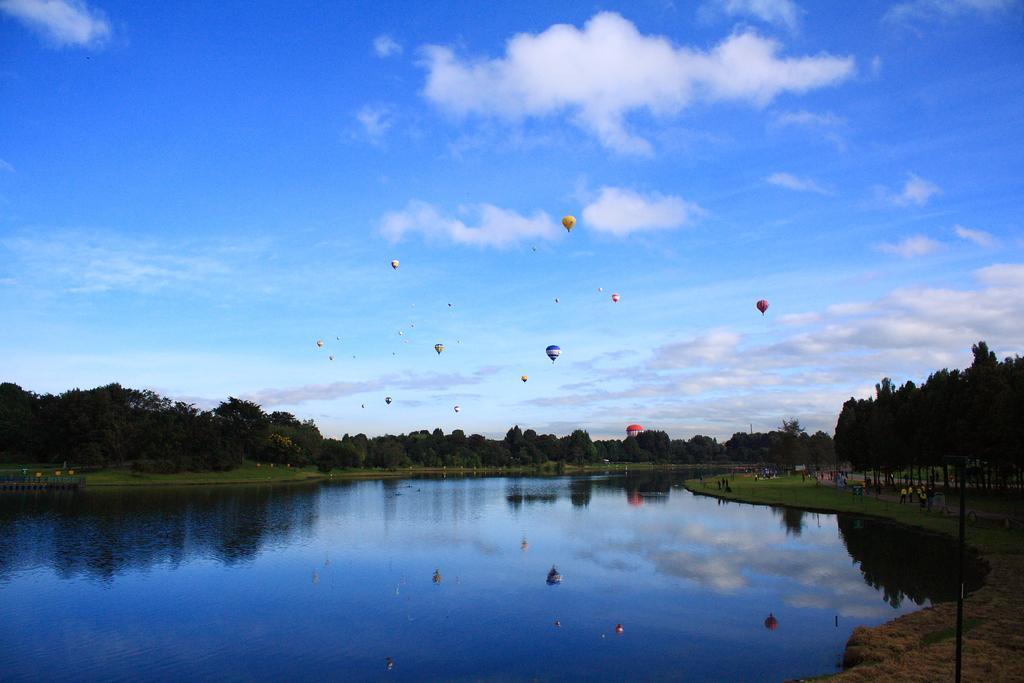How would you summarize this image in a sentence or two? In this image I can see water in the centre. On the both sides of the water I can see grass grounds, number of trees and on the right side of the image I can see number of people. In the background I can see a building, number of air balloons in the air, clouds and the sky. I can also see reflection on the water and on the bottom right side of the image I can see a black colour pole. 